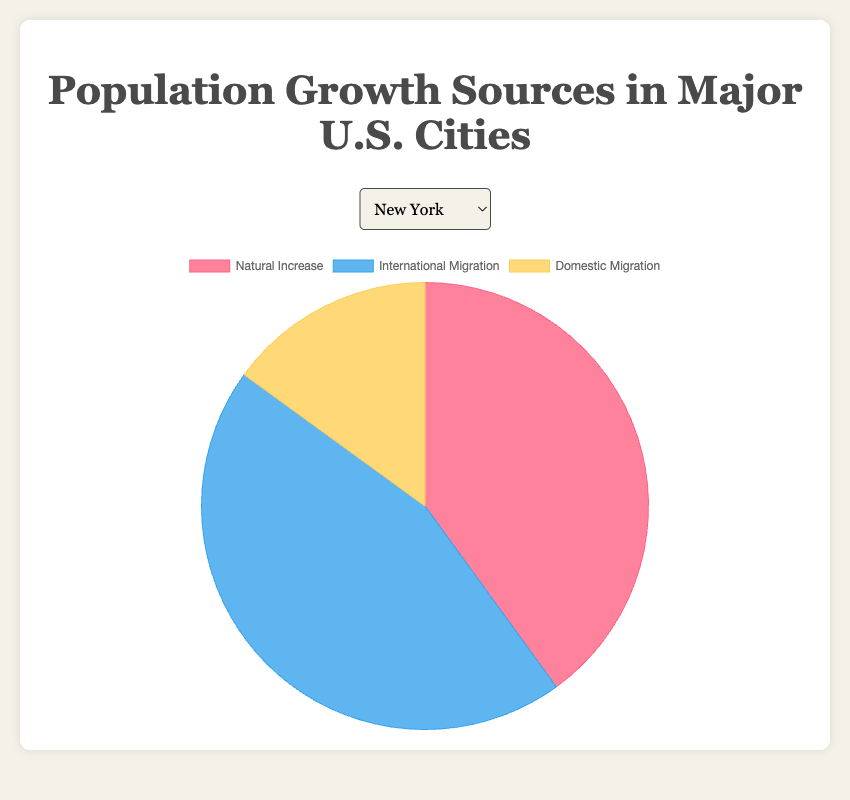Which city has the highest percentage of population growth from international migration? Look at the pie charts for each city and check the segment sizes labeled "International Migration." New York has the largest segment for international migration, forming 45% of its total population growth sources.
Answer: New York Which city has a greater combined percentage of natural increase and domestic migration: Phoenix or San Diego? Calculate the combined percentage of natural increase and domestic migration for both cities. For Phoenix, it's 28% + 47% = 75%. For San Diego, it's 20% + 45% = 65%. Phoenix has a greater combined percentage.
Answer: Phoenix For Houston, what fraction of the total population growth sources comes from natural increase? From the pie chart for Houston, the natural increase is 35%. Convert this percentage to a fraction: 35% = 35/100, which simplifies to 7/20.
Answer: 7/20 Compare the contribution of domestic migration in Chicago and San Jose. Which city has a higher percentage and by how much? Domestic migration in Chicago is 45%, while in San Jose it is 42%. The difference is 45% - 42% = 3%. Chicago has a higher percentage by 3%.
Answer: Chicago, 3% What is the average percentage of international migration across all cities? Sum all international migration percentages: 45 + 35 + 30 + 40 + 25 + 30 + 30 + 35 + 28 + 40 = 338. Then divide by the number of cities: 338 / 10 = 33.8%. The average is 33.8%.
Answer: 33.8% Which city has the least contribution from natural increase? Look at the pie chart segments labeled "Natural Increase" for each city. San Jose has the smallest segment, indicating 18% from natural increase.
Answer: San Jose Is the percentage for domestic migration in Philadelphia higher than the combined percentage for natural increase and international migration? For Philadelphia, natural increase is 40%, and international migration is 30%. Combined, they make 70%. Domestic migration is 30%, which is less than 70%.
Answer: No In Los Angeles, what is the ratio of natural increase to domestic migration? Both natural increase and domestic migration in Los Angeles are 30% and 35% respectively. The ratio is 30:35, which simplifies to 6:7.
Answer: 6:7 In Houston, how does the percentage of international migration compare to natural increase and domestic migration combined? For Houston, international migration is 40%, while natural increase is 35% and domestic migration is 25%, combined being 60%. 40% is less than 60%.
Answer: Less What is the median percentage of natural increase across all cities? List the natural increase percentages: 40, 30, 25, 35, 28, 40, 33, 20, 32, 18. Order them: 18, 20, 25, 28, 30, 32, 33, 35, 40, 40. The median is the average of the 5th and 6th values: (30 + 32) / 2 = 31%.
Answer: 31% 